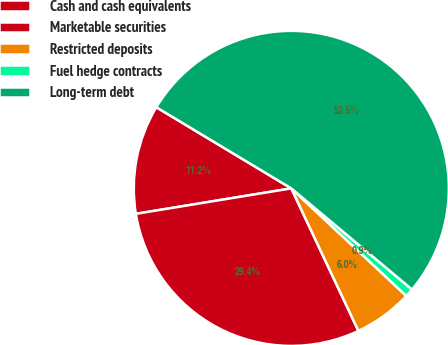Convert chart to OTSL. <chart><loc_0><loc_0><loc_500><loc_500><pie_chart><fcel>Cash and cash equivalents<fcel>Marketable securities<fcel>Restricted deposits<fcel>Fuel hedge contracts<fcel>Long-term debt<nl><fcel>11.2%<fcel>29.42%<fcel>6.03%<fcel>0.87%<fcel>52.48%<nl></chart> 